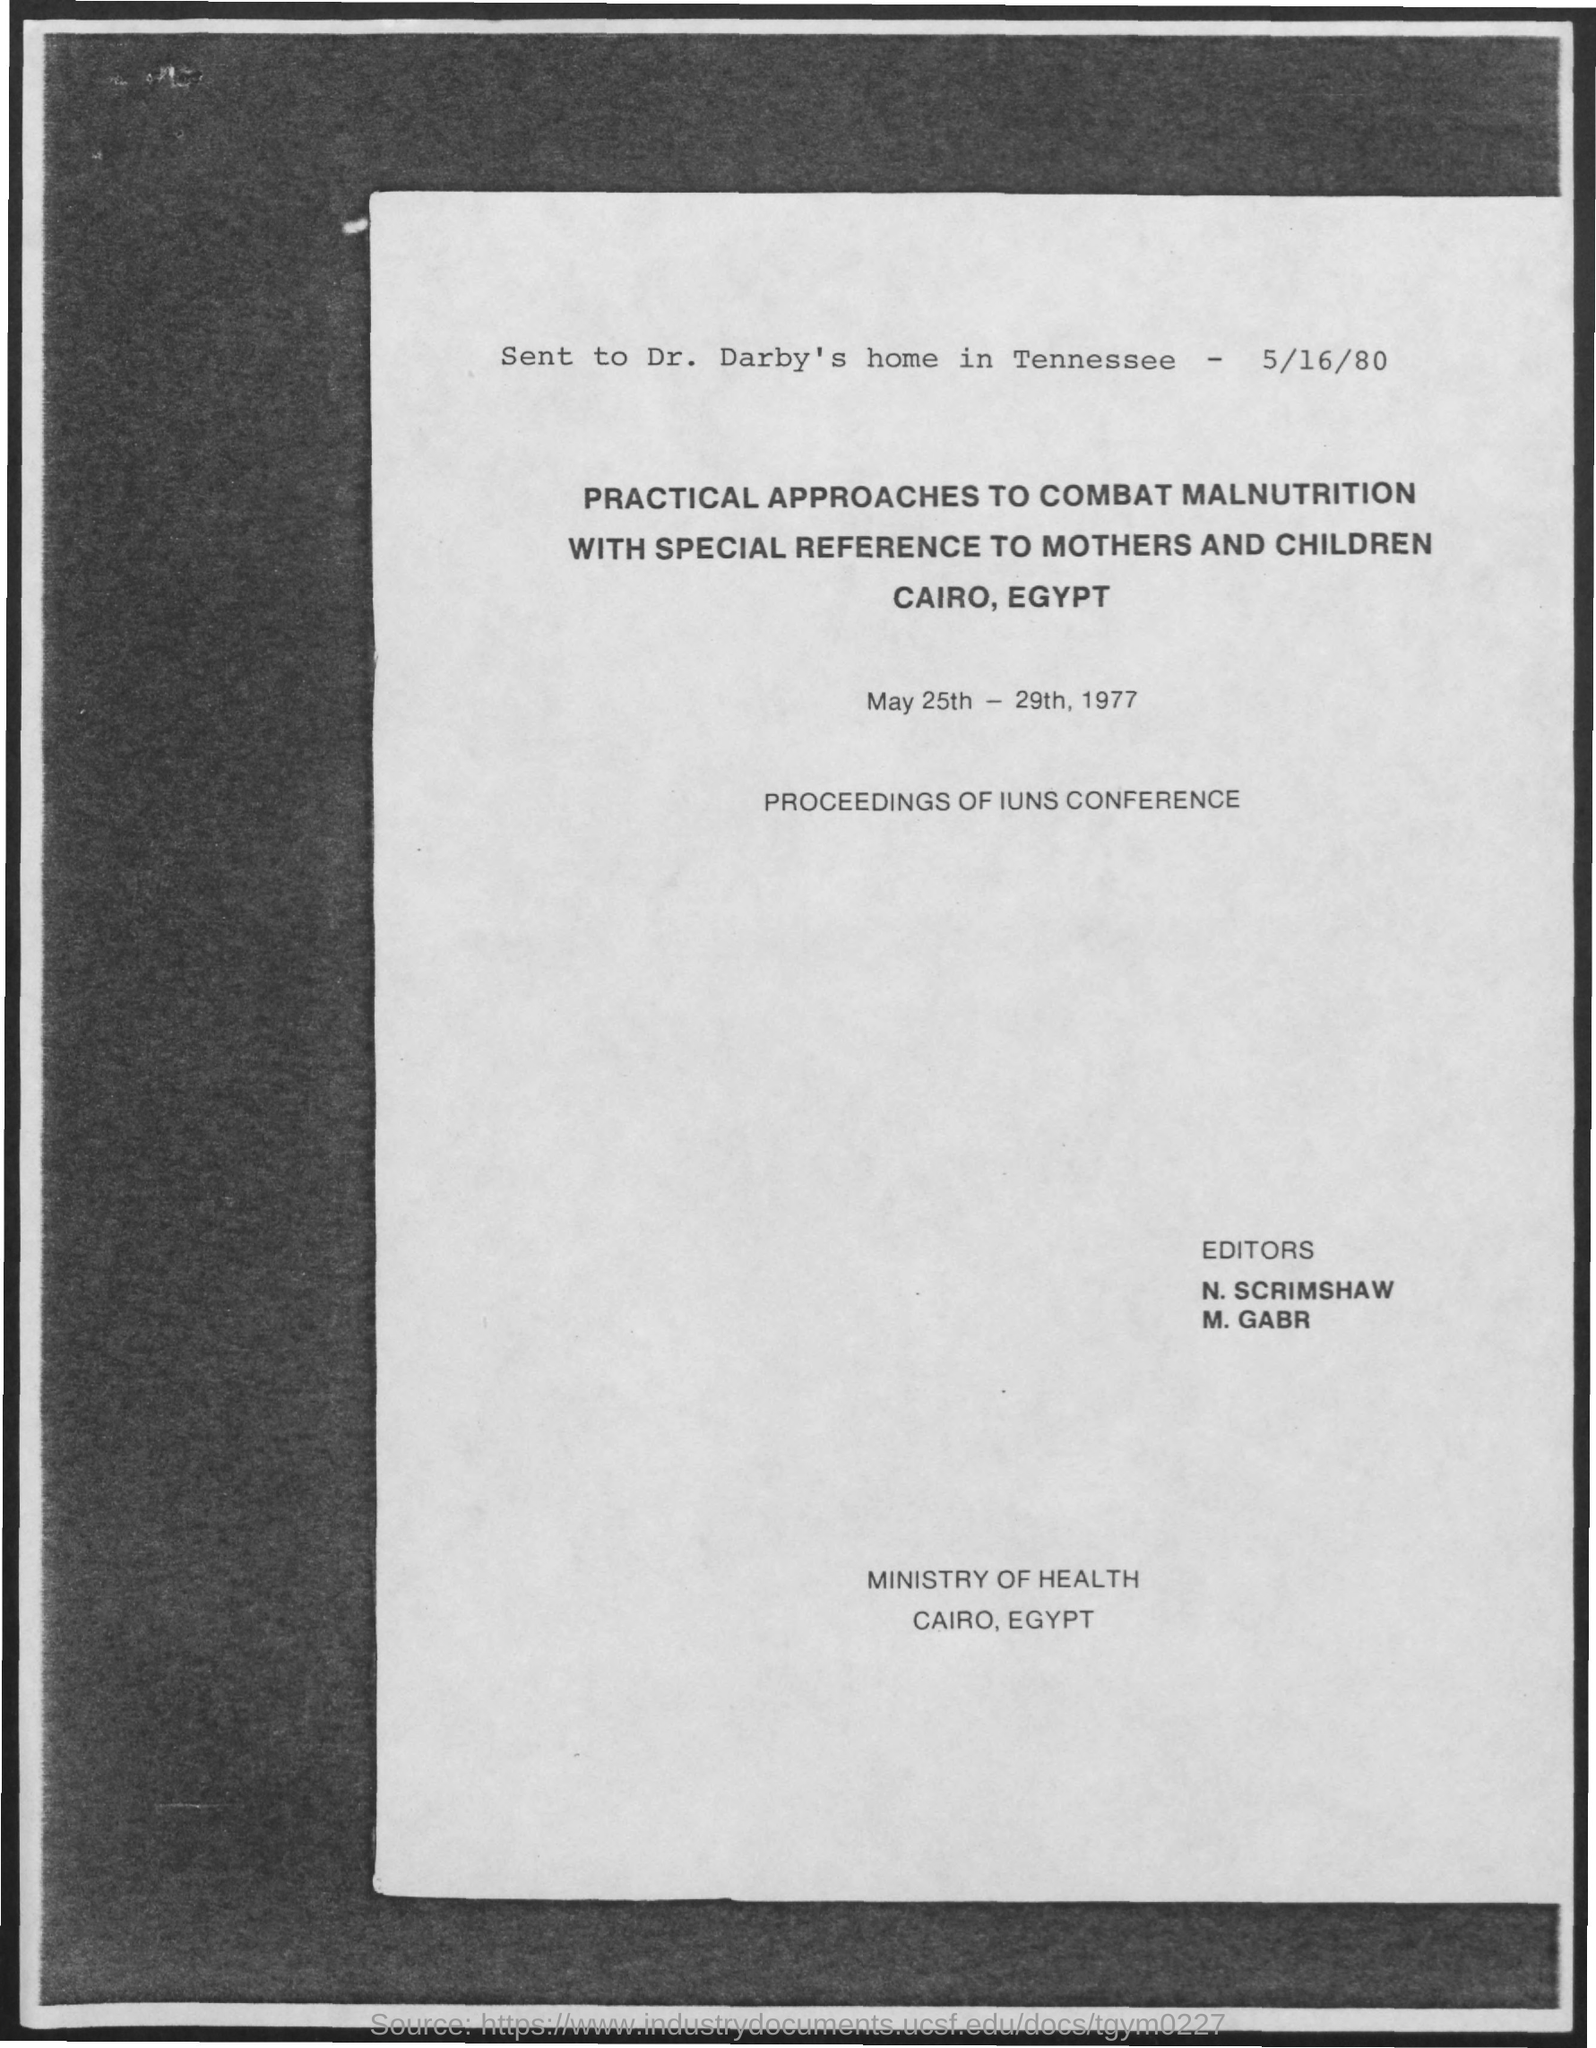Who is it sent to?
Your answer should be very brief. Dr. Darby's. Where was it sent?
Ensure brevity in your answer.  Home in Tennessee. What date was it sent?
Your response must be concise. 5/16/80. When is the conference?
Offer a terse response. May 25th - 29th, 1977. Where is the Ministry of health located?
Offer a terse response. CAIRO, EGYPT. 